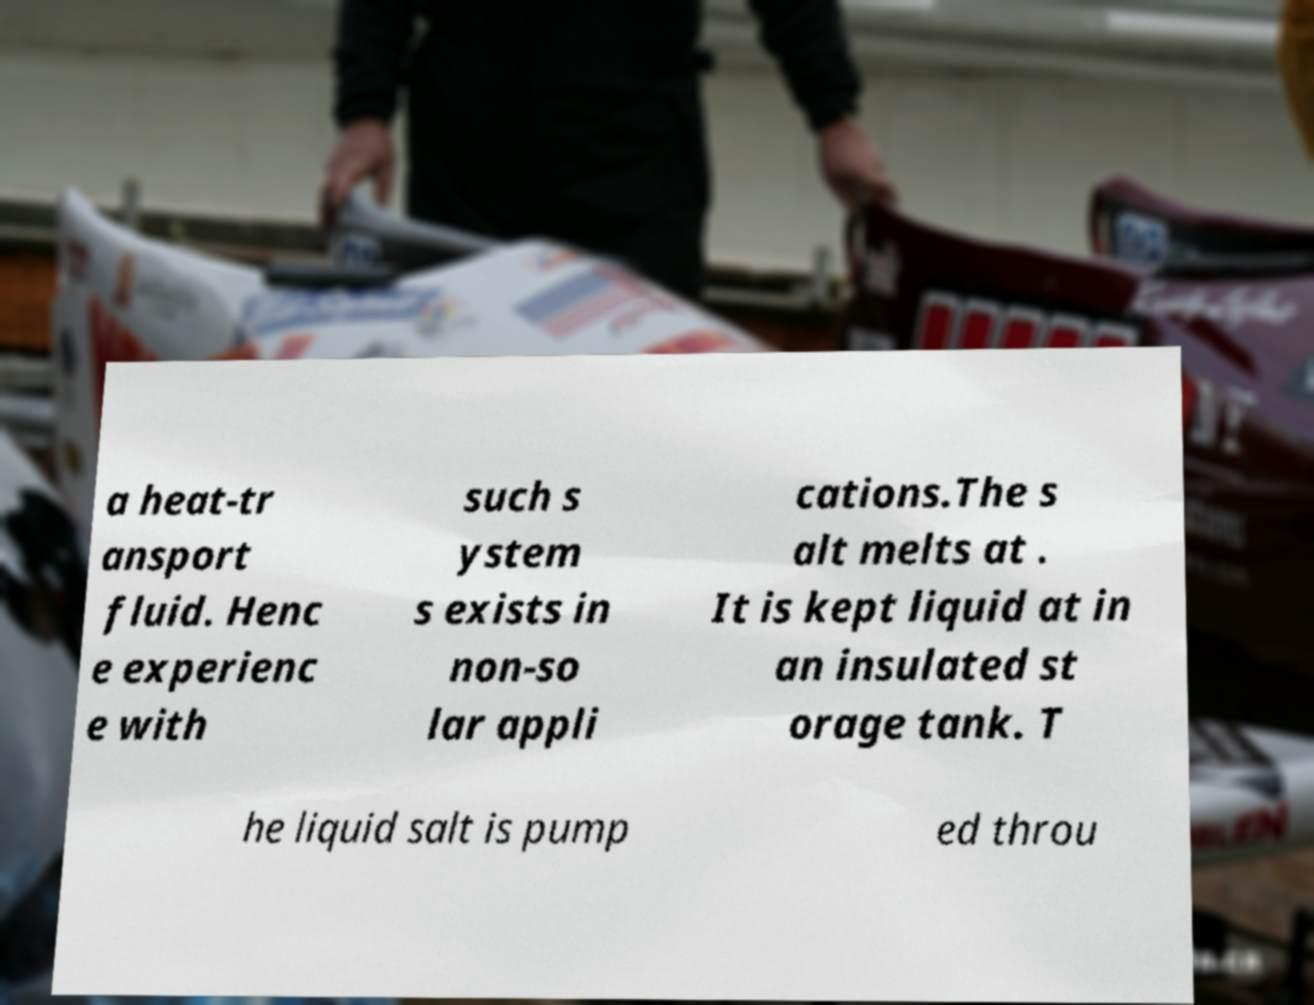For documentation purposes, I need the text within this image transcribed. Could you provide that? a heat-tr ansport fluid. Henc e experienc e with such s ystem s exists in non-so lar appli cations.The s alt melts at . It is kept liquid at in an insulated st orage tank. T he liquid salt is pump ed throu 